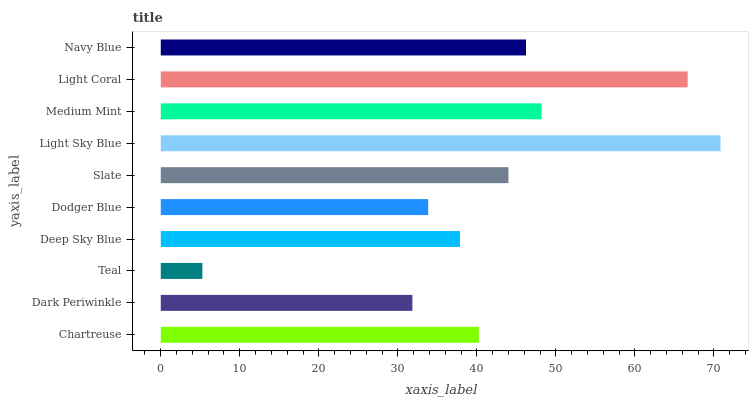Is Teal the minimum?
Answer yes or no. Yes. Is Light Sky Blue the maximum?
Answer yes or no. Yes. Is Dark Periwinkle the minimum?
Answer yes or no. No. Is Dark Periwinkle the maximum?
Answer yes or no. No. Is Chartreuse greater than Dark Periwinkle?
Answer yes or no. Yes. Is Dark Periwinkle less than Chartreuse?
Answer yes or no. Yes. Is Dark Periwinkle greater than Chartreuse?
Answer yes or no. No. Is Chartreuse less than Dark Periwinkle?
Answer yes or no. No. Is Slate the high median?
Answer yes or no. Yes. Is Chartreuse the low median?
Answer yes or no. Yes. Is Teal the high median?
Answer yes or no. No. Is Light Coral the low median?
Answer yes or no. No. 